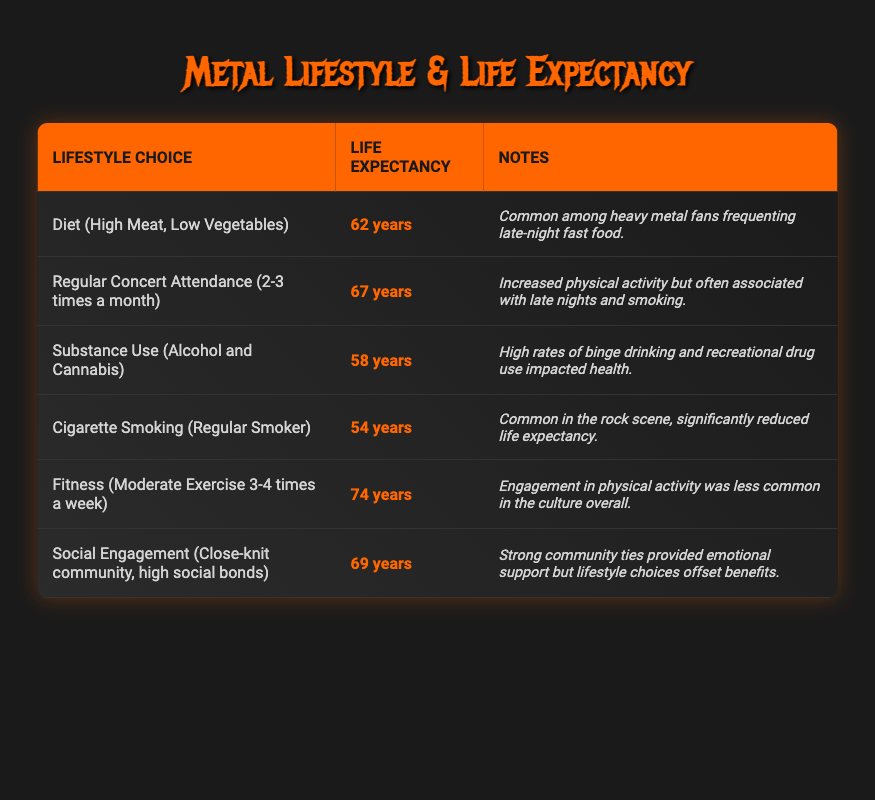What is the average life expectancy for those who smoke cigarettes regularly? The table states that regular smokers have an average life expectancy of 54 years, which is clearly listed in the respective row for that lifestyle choice.
Answer: 54 years How does the average life expectancy of individuals who engage in regular concert attendance compare to those who have a high meat, low vegetable diet? The average life expectancy for regular concert attendees is 67 years, while those with a high meat diet have an average of 62 years. Comparing these values: 67 - 62 = 5, indicating regular concert attendees live 5 years longer on average.
Answer: 5 years longer Is it true that the average life expectancy for substance users is lower than for those with moderate exercise? Yes, the average life expectancy for substance users is 58 years, and for those who exercise moderately, it is 74 years. Since 58 is less than 74, this statement is true.
Answer: Yes What is the average life expectancy for metal fans who have strong social engagement? In the table, it shows that individuals with close-knit community ties have an average life expectancy of 69 years, which is stated in the relevant section about social engagement.
Answer: 69 years If a person stops cigarette smoking, shifts to a fitness routine of moderate exercise, and stops substance use, what change in average life expectancy can be expected? First, the average life expectancy for a regular smoker is 54 years. For moderate exercise, it’s 74 years, and for substance use, it’s 58 years. The change after stopping smoking (54 to 74) is an increase of 20 years. Additionally, stopping substance use (58 to 74) results in another increase of 16 years. Therefore, the total potential change in average life expectancy is 20 + 16 = 36 years.
Answer: 36 years What lifestyle choice correlates with the shortest average life expectancy? Review the lifestyle choices listed in the table, where it is noted that regular smokers have the shortest average life expectancy at 54 years. This is the lowest value when compared to the life expectancies associated with other lifestyle choices.
Answer: Cigarette smoking 